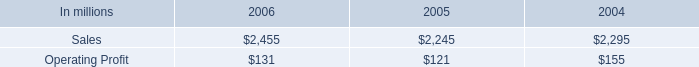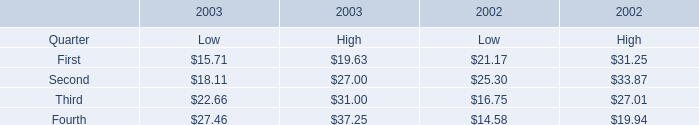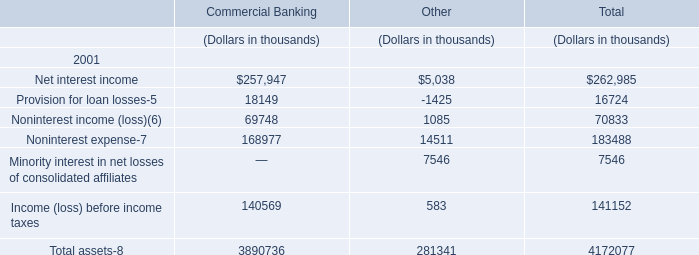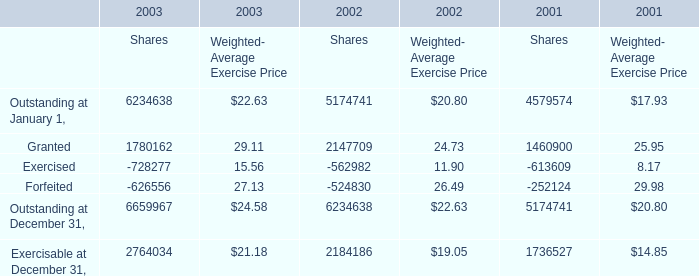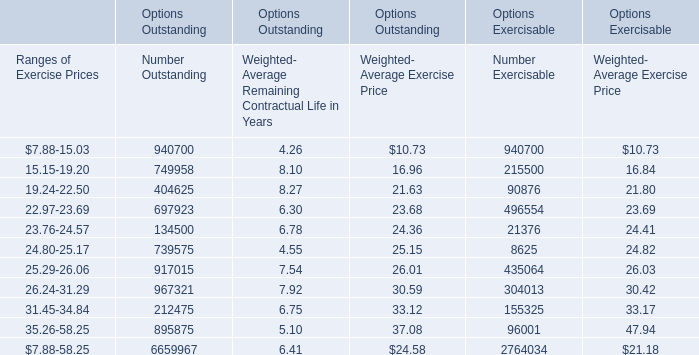How much was the Weighted- Average Exercise Price for Ranges of Exercise Prices:24.80-25.17 in terms of Options Outstanding as As the chart 4 shows? 
Answer: 25.15. 